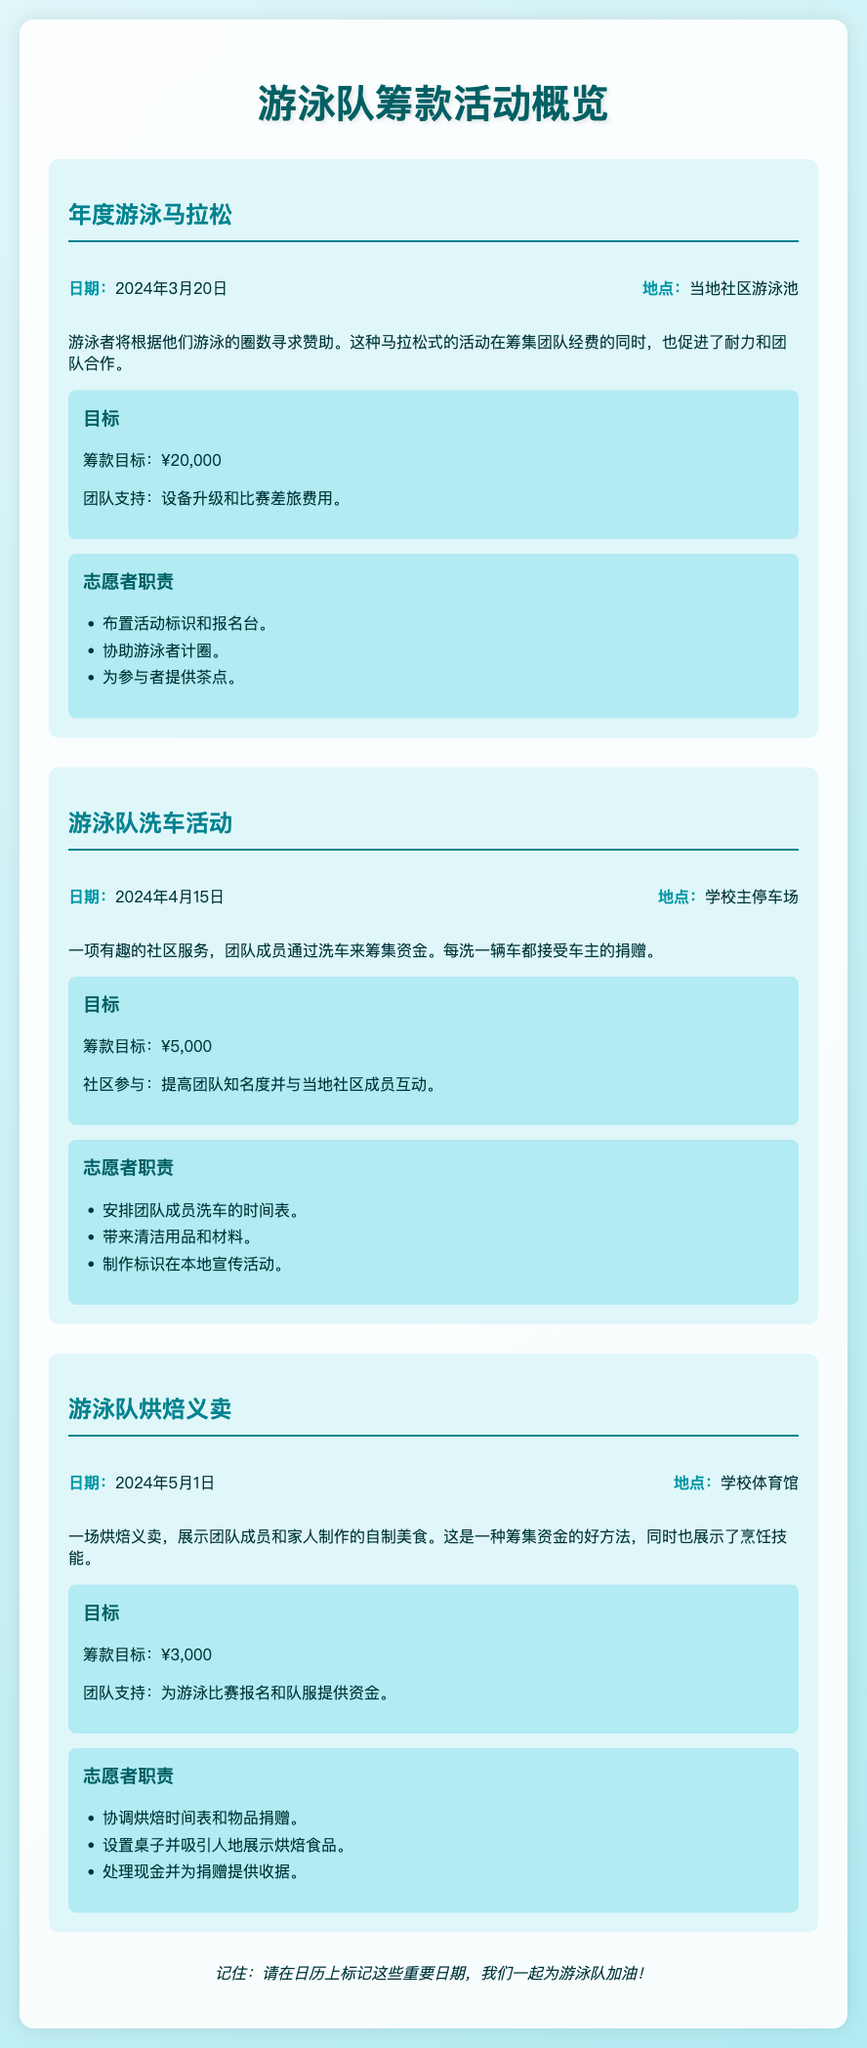什么是年度游泳马拉松的日期？ 这是文档中提到的特定事件日期，其中包含“2024年3月20日”。
Answer: 2024年3月20日 年度游泳马拉松的筹款目标是多少？ 通过文档中的信息，我们可以得到这个特定活动的财务目标，它是“¥20,000”。
Answer: ¥20,000 游泳队洗车活动的地点在哪里？ 这是根据文档中描述的活动地点，可以直接找到“学校主停车场”。
Answer: 学校主停车场 游泳队烘焙义卖的筹款目标是多少？ 该信息可以在描述该事件的目标部分找到，具体为“¥3,000”。
Answer: ¥3,000 志愿者在年度游泳马拉松中负责什么任务？ 根据文档，志愿者的职责在该活动的介绍中列出，如“布置活动标识和报名台”。
Answer: 布置活动标识和报名台 年度游泳马拉松的目标是？ 文档中的目标部分说明了该活动的目的，可以找到“设备升级和比赛差旅费用”。
Answer: 设备升级和比赛差旅费用 游泳队洗车活动的筹款目标相较于其他活动如何？ 需要比对各事件的筹款目标，这里列为“¥5,000”，在所有活动中最低。
Answer: 最低 志愿者在洗车活动中需要带什么？ 根据志愿者职责的说明，文档提到应“带来清洁用品和材料”。
Answer: 清洁用品和材料 游泳队烘焙义卖的地点是什么？ 此信息在事件详情部分直接提供，为“学校体育馆”。
Answer: 学校体育馆 